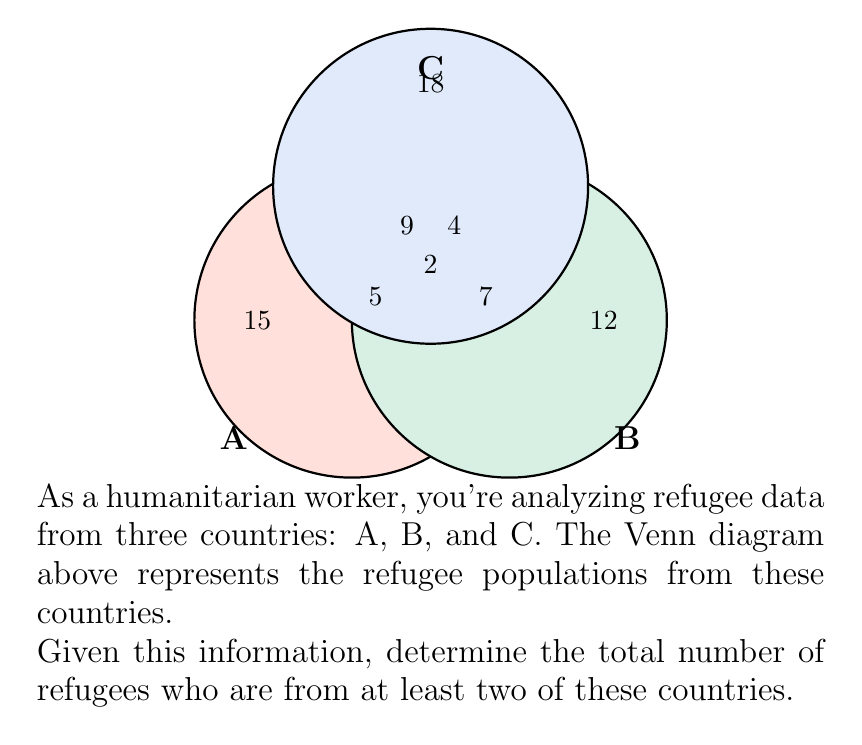Provide a solution to this math problem. Let's approach this step-by-step:

1) First, we need to identify the regions in the Venn diagram that represent refugees from at least two countries. These are:
   - The intersection of A and B (but not C)
   - The intersection of B and C (but not A)
   - The intersection of A and C (but not B)
   - The intersection of all three countries (A, B, and C)

2) Now, let's sum up these values:
   $$(A \cap B) \setminus C = 5$$
   $$(B \cap C) \setminus A = 4$$
   $$(A \cap C) \setminus B = 9$$
   $$A \cap B \cap C = 2$$

3) The total is the sum of these values:
   $$5 + 4 + 9 + 2 = 20$$

Therefore, the total number of refugees who are from at least two of these countries is 20.
Answer: 20 